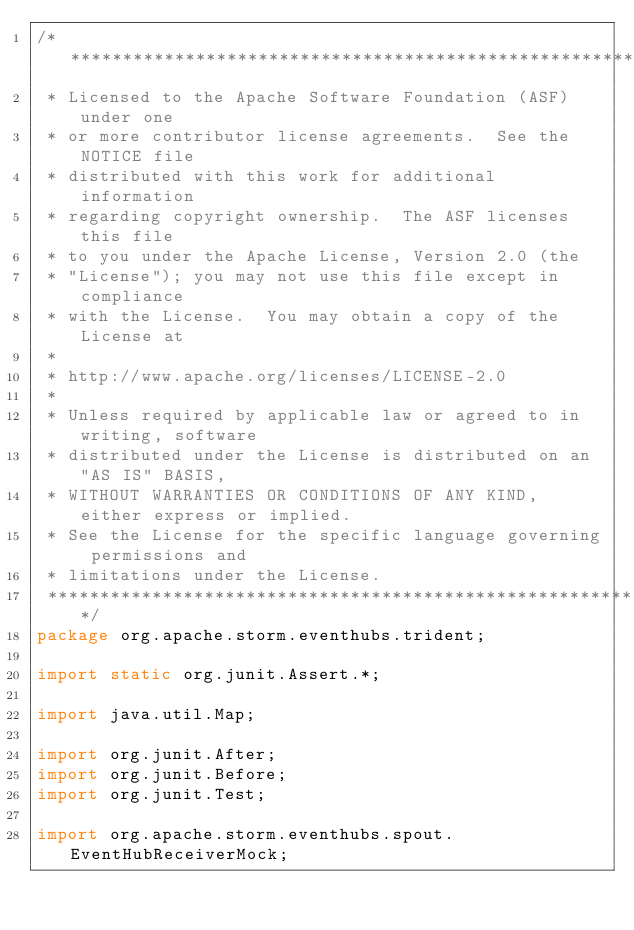Convert code to text. <code><loc_0><loc_0><loc_500><loc_500><_Java_>/*******************************************************************************
 * Licensed to the Apache Software Foundation (ASF) under one
 * or more contributor license agreements.  See the NOTICE file
 * distributed with this work for additional information
 * regarding copyright ownership.  The ASF licenses this file
 * to you under the Apache License, Version 2.0 (the
 * "License"); you may not use this file except in compliance
 * with the License.  You may obtain a copy of the License at
 *
 * http://www.apache.org/licenses/LICENSE-2.0
 *
 * Unless required by applicable law or agreed to in writing, software
 * distributed under the License is distributed on an "AS IS" BASIS,
 * WITHOUT WARRANTIES OR CONDITIONS OF ANY KIND, either express or implied.
 * See the License for the specific language governing permissions and
 * limitations under the License.
 *******************************************************************************/
package org.apache.storm.eventhubs.trident;

import static org.junit.Assert.*;

import java.util.Map;

import org.junit.After;
import org.junit.Before;
import org.junit.Test;

import org.apache.storm.eventhubs.spout.EventHubReceiverMock;</code> 